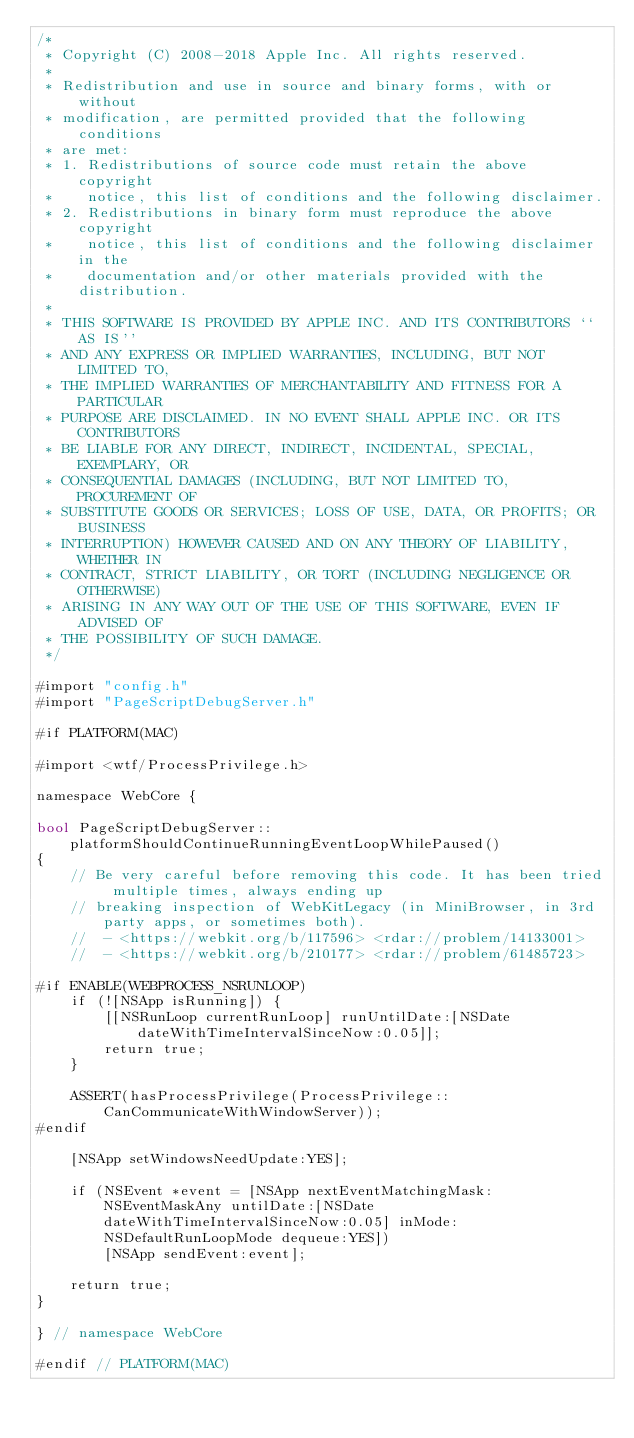<code> <loc_0><loc_0><loc_500><loc_500><_ObjectiveC_>/*
 * Copyright (C) 2008-2018 Apple Inc. All rights reserved.
 *
 * Redistribution and use in source and binary forms, with or without
 * modification, are permitted provided that the following conditions
 * are met:
 * 1. Redistributions of source code must retain the above copyright
 *    notice, this list of conditions and the following disclaimer.
 * 2. Redistributions in binary form must reproduce the above copyright
 *    notice, this list of conditions and the following disclaimer in the
 *    documentation and/or other materials provided with the distribution.
 *
 * THIS SOFTWARE IS PROVIDED BY APPLE INC. AND ITS CONTRIBUTORS ``AS IS''
 * AND ANY EXPRESS OR IMPLIED WARRANTIES, INCLUDING, BUT NOT LIMITED TO,
 * THE IMPLIED WARRANTIES OF MERCHANTABILITY AND FITNESS FOR A PARTICULAR
 * PURPOSE ARE DISCLAIMED. IN NO EVENT SHALL APPLE INC. OR ITS CONTRIBUTORS
 * BE LIABLE FOR ANY DIRECT, INDIRECT, INCIDENTAL, SPECIAL, EXEMPLARY, OR
 * CONSEQUENTIAL DAMAGES (INCLUDING, BUT NOT LIMITED TO, PROCUREMENT OF
 * SUBSTITUTE GOODS OR SERVICES; LOSS OF USE, DATA, OR PROFITS; OR BUSINESS
 * INTERRUPTION) HOWEVER CAUSED AND ON ANY THEORY OF LIABILITY, WHETHER IN
 * CONTRACT, STRICT LIABILITY, OR TORT (INCLUDING NEGLIGENCE OR OTHERWISE)
 * ARISING IN ANY WAY OUT OF THE USE OF THIS SOFTWARE, EVEN IF ADVISED OF
 * THE POSSIBILITY OF SUCH DAMAGE.
 */

#import "config.h"
#import "PageScriptDebugServer.h"

#if PLATFORM(MAC)

#import <wtf/ProcessPrivilege.h>

namespace WebCore {

bool PageScriptDebugServer::platformShouldContinueRunningEventLoopWhilePaused()
{
    // Be very careful before removing this code. It has been tried multiple times, always ending up
    // breaking inspection of WebKitLegacy (in MiniBrowser, in 3rd party apps, or sometimes both).
    //  - <https://webkit.org/b/117596> <rdar://problem/14133001>
    //  - <https://webkit.org/b/210177> <rdar://problem/61485723>

#if ENABLE(WEBPROCESS_NSRUNLOOP)
    if (![NSApp isRunning]) {
        [[NSRunLoop currentRunLoop] runUntilDate:[NSDate dateWithTimeIntervalSinceNow:0.05]];
        return true;
    }

    ASSERT(hasProcessPrivilege(ProcessPrivilege::CanCommunicateWithWindowServer));
#endif

    [NSApp setWindowsNeedUpdate:YES];

    if (NSEvent *event = [NSApp nextEventMatchingMask:NSEventMaskAny untilDate:[NSDate dateWithTimeIntervalSinceNow:0.05] inMode:NSDefaultRunLoopMode dequeue:YES])
        [NSApp sendEvent:event];

    return true;
}

} // namespace WebCore

#endif // PLATFORM(MAC)
</code> 